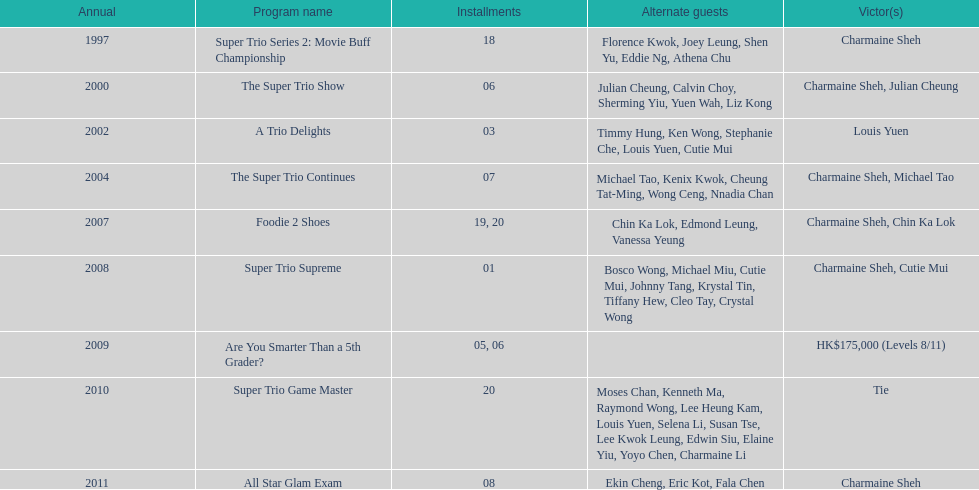How many episodes was charmaine sheh on in the variety show super trio 2: movie buff champions 18. Can you parse all the data within this table? {'header': ['Annual', 'Program name', 'Installments', 'Alternate guests', 'Victor(s)'], 'rows': [['1997', 'Super Trio Series 2: Movie Buff Championship', '18', 'Florence Kwok, Joey Leung, Shen Yu, Eddie Ng, Athena Chu', 'Charmaine Sheh'], ['2000', 'The Super Trio Show', '06', 'Julian Cheung, Calvin Choy, Sherming Yiu, Yuen Wah, Liz Kong', 'Charmaine Sheh, Julian Cheung'], ['2002', 'A Trio Delights', '03', 'Timmy Hung, Ken Wong, Stephanie Che, Louis Yuen, Cutie Mui', 'Louis Yuen'], ['2004', 'The Super Trio Continues', '07', 'Michael Tao, Kenix Kwok, Cheung Tat-Ming, Wong Ceng, Nnadia Chan', 'Charmaine Sheh, Michael Tao'], ['2007', 'Foodie 2 Shoes', '19, 20', 'Chin Ka Lok, Edmond Leung, Vanessa Yeung', 'Charmaine Sheh, Chin Ka Lok'], ['2008', 'Super Trio Supreme', '01', 'Bosco Wong, Michael Miu, Cutie Mui, Johnny Tang, Krystal Tin, Tiffany Hew, Cleo Tay, Crystal Wong', 'Charmaine Sheh, Cutie Mui'], ['2009', 'Are You Smarter Than a 5th Grader?', '05, 06', '', 'HK$175,000 (Levels 8/11)'], ['2010', 'Super Trio Game Master', '20', 'Moses Chan, Kenneth Ma, Raymond Wong, Lee Heung Kam, Louis Yuen, Selena Li, Susan Tse, Lee Kwok Leung, Edwin Siu, Elaine Yiu, Yoyo Chen, Charmaine Li', 'Tie'], ['2011', 'All Star Glam Exam', '08', 'Ekin Cheng, Eric Kot, Fala Chen', 'Charmaine Sheh']]} 